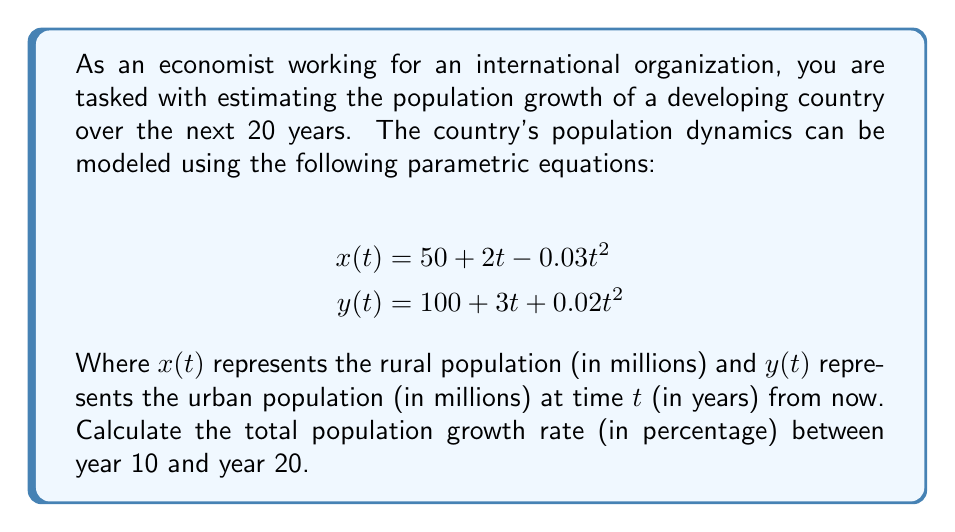Provide a solution to this math problem. To solve this problem, we need to follow these steps:

1. Calculate the total population at year 10 and year 20.
2. Compute the population growth between these two time points.
3. Calculate the growth rate as a percentage.

Step 1: Calculate total population at t = 10 and t = 20

For t = 10:
$$\begin{align}
x(10) &= 50 + 2(10) - 0.03(10)^2 = 50 + 20 - 3 = 67 \text{ million} \\
y(10) &= 100 + 3(10) + 0.02(10)^2 = 100 + 30 + 2 = 132 \text{ million}
\end{align}$$

Total population at t = 10: $67 + 132 = 199 \text{ million}$

For t = 20:
$$\begin{align}
x(20) &= 50 + 2(20) - 0.03(20)^2 = 50 + 40 - 12 = 78 \text{ million} \\
y(20) &= 100 + 3(20) + 0.02(20)^2 = 100 + 60 + 8 = 168 \text{ million}
\end{align}$$

Total population at t = 20: $78 + 168 = 246 \text{ million}$

Step 2: Compute population growth
Population growth = $246 - 199 = 47 \text{ million}$

Step 3: Calculate growth rate as a percentage
Growth rate = $\frac{\text{Population growth}}{\text{Initial population}} \times 100\%$
$$= \frac{47}{199} \times 100\% \approx 23.62\%$$

To get the annual growth rate, we divide by the number of years (10):
Annual growth rate $\approx 23.62\% \div 10 = 2.362\%$
Answer: The total population growth rate between year 10 and year 20 is approximately 23.62%, or 2.362% annually. 